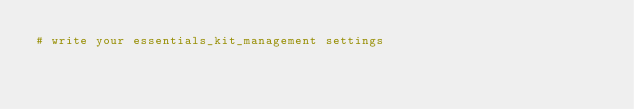Convert code to text. <code><loc_0><loc_0><loc_500><loc_500><_Python_># write your essentials_kit_management settings</code> 